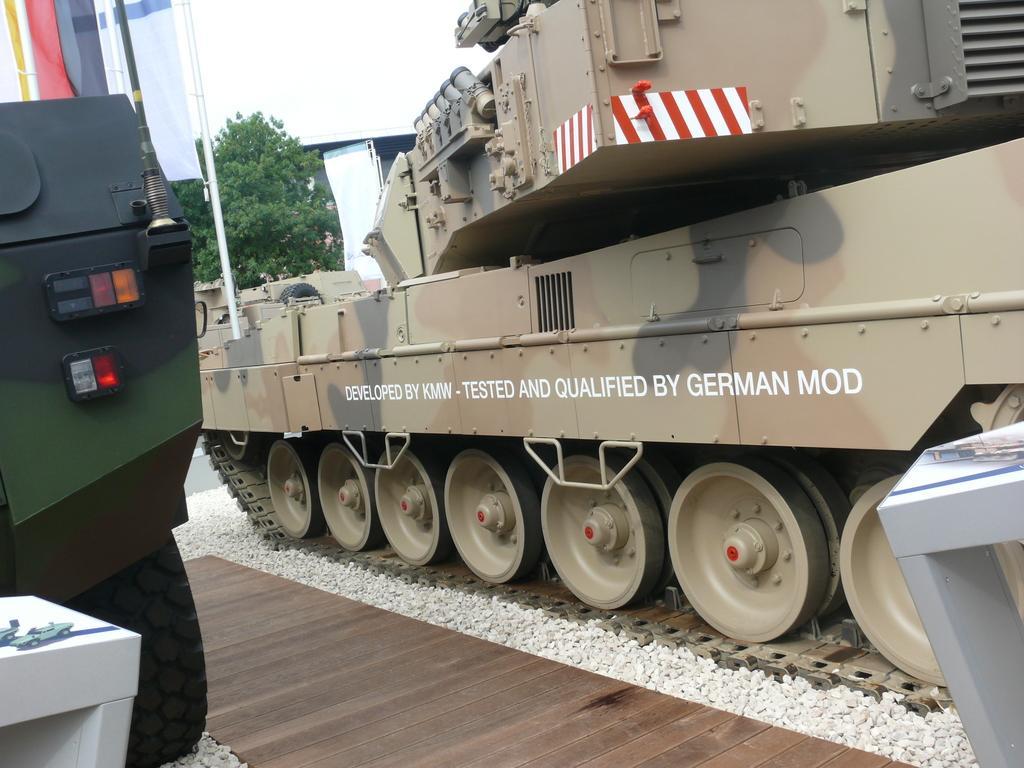Describe this image in one or two sentences. In this picture, it seems like army vehicles in the foreground area of the image, there is a tree and the sky in the background. 